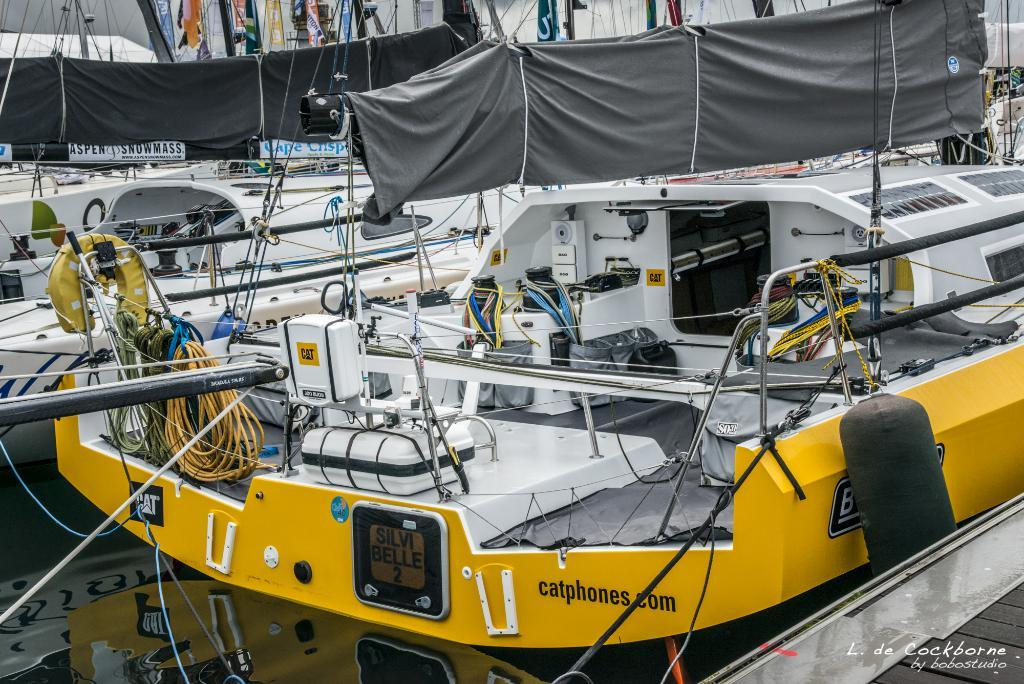What is the main subject of the image? The main subject of the image is many ships. What type of equipment can be found on the ships? The ships contain wire and electrical equipment. What is the name of the partner who works on the ships in the image? There is no information about a partner or any individuals working on the ships in the image. 